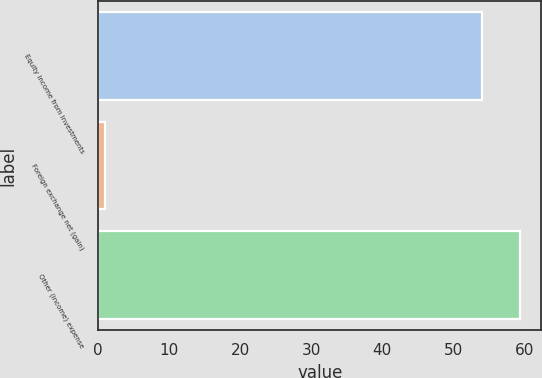<chart> <loc_0><loc_0><loc_500><loc_500><bar_chart><fcel>Equity income from investments<fcel>Foreign exchange net (gain)<fcel>Other (income) expense<nl><fcel>54<fcel>1<fcel>59.4<nl></chart> 